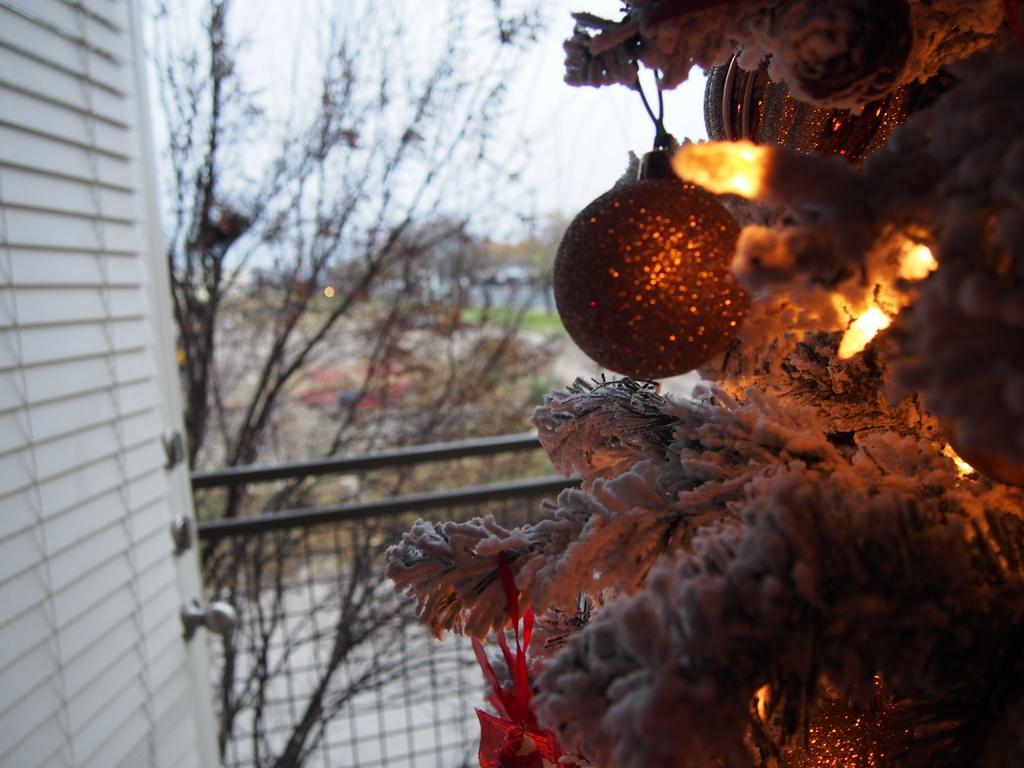Please provide a concise description of this image. On the right side of the image we can see one Christmas tree. On the Christmas tree, we can see the lights and some decorative items. In the background, we can see the sky, clouds, trees, fences and wooden door. 